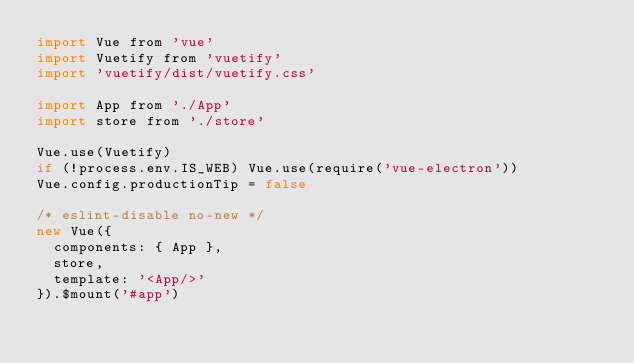Convert code to text. <code><loc_0><loc_0><loc_500><loc_500><_JavaScript_>import Vue from 'vue'
import Vuetify from 'vuetify'
import 'vuetify/dist/vuetify.css'

import App from './App'
import store from './store'

Vue.use(Vuetify)
if (!process.env.IS_WEB) Vue.use(require('vue-electron'))
Vue.config.productionTip = false

/* eslint-disable no-new */
new Vue({
  components: { App },
  store,
  template: '<App/>'
}).$mount('#app')
</code> 